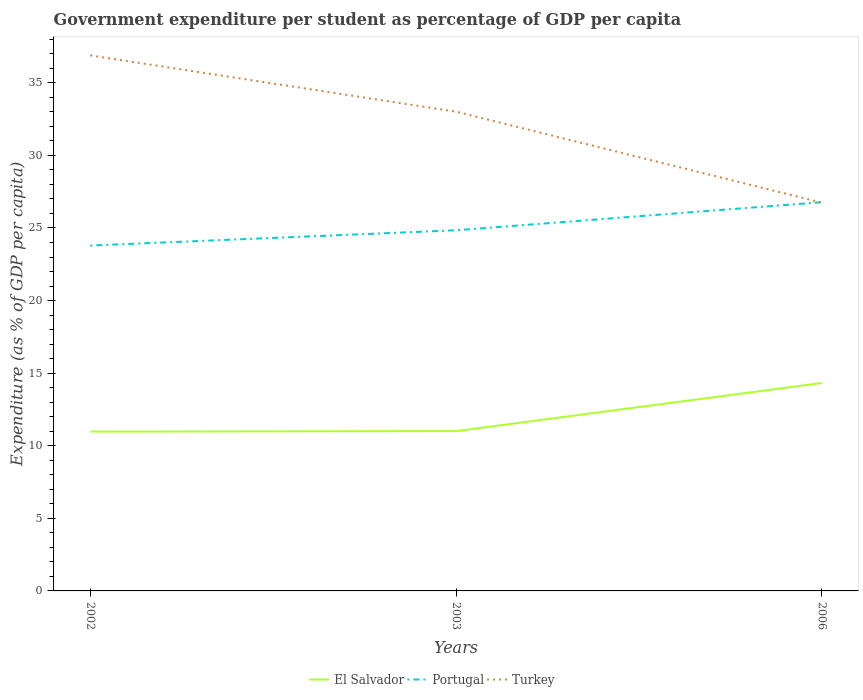How many different coloured lines are there?
Your answer should be compact. 3. Is the number of lines equal to the number of legend labels?
Provide a succinct answer. Yes. Across all years, what is the maximum percentage of expenditure per student in El Salvador?
Ensure brevity in your answer.  10.97. In which year was the percentage of expenditure per student in Portugal maximum?
Make the answer very short. 2002. What is the total percentage of expenditure per student in Portugal in the graph?
Ensure brevity in your answer.  -2.99. What is the difference between the highest and the second highest percentage of expenditure per student in Portugal?
Keep it short and to the point. 2.99. What is the difference between the highest and the lowest percentage of expenditure per student in Turkey?
Provide a succinct answer. 2. Is the percentage of expenditure per student in El Salvador strictly greater than the percentage of expenditure per student in Portugal over the years?
Offer a very short reply. Yes. How many lines are there?
Keep it short and to the point. 3. How many years are there in the graph?
Ensure brevity in your answer.  3. What is the difference between two consecutive major ticks on the Y-axis?
Ensure brevity in your answer.  5. Are the values on the major ticks of Y-axis written in scientific E-notation?
Your answer should be very brief. No. Does the graph contain any zero values?
Provide a short and direct response. No. Does the graph contain grids?
Provide a succinct answer. No. Where does the legend appear in the graph?
Give a very brief answer. Bottom center. What is the title of the graph?
Make the answer very short. Government expenditure per student as percentage of GDP per capita. Does "Solomon Islands" appear as one of the legend labels in the graph?
Your answer should be compact. No. What is the label or title of the Y-axis?
Your answer should be very brief. Expenditure (as % of GDP per capita). What is the Expenditure (as % of GDP per capita) in El Salvador in 2002?
Your answer should be very brief. 10.97. What is the Expenditure (as % of GDP per capita) in Portugal in 2002?
Provide a short and direct response. 23.79. What is the Expenditure (as % of GDP per capita) in Turkey in 2002?
Keep it short and to the point. 36.89. What is the Expenditure (as % of GDP per capita) in El Salvador in 2003?
Provide a short and direct response. 11.01. What is the Expenditure (as % of GDP per capita) of Portugal in 2003?
Provide a succinct answer. 24.84. What is the Expenditure (as % of GDP per capita) in Turkey in 2003?
Keep it short and to the point. 33.01. What is the Expenditure (as % of GDP per capita) in El Salvador in 2006?
Provide a short and direct response. 14.32. What is the Expenditure (as % of GDP per capita) of Portugal in 2006?
Your answer should be very brief. 26.78. What is the Expenditure (as % of GDP per capita) of Turkey in 2006?
Give a very brief answer. 26.74. Across all years, what is the maximum Expenditure (as % of GDP per capita) in El Salvador?
Your answer should be compact. 14.32. Across all years, what is the maximum Expenditure (as % of GDP per capita) of Portugal?
Offer a terse response. 26.78. Across all years, what is the maximum Expenditure (as % of GDP per capita) of Turkey?
Offer a very short reply. 36.89. Across all years, what is the minimum Expenditure (as % of GDP per capita) in El Salvador?
Give a very brief answer. 10.97. Across all years, what is the minimum Expenditure (as % of GDP per capita) of Portugal?
Offer a very short reply. 23.79. Across all years, what is the minimum Expenditure (as % of GDP per capita) of Turkey?
Give a very brief answer. 26.74. What is the total Expenditure (as % of GDP per capita) of El Salvador in the graph?
Keep it short and to the point. 36.3. What is the total Expenditure (as % of GDP per capita) of Portugal in the graph?
Offer a very short reply. 75.41. What is the total Expenditure (as % of GDP per capita) in Turkey in the graph?
Give a very brief answer. 96.64. What is the difference between the Expenditure (as % of GDP per capita) in El Salvador in 2002 and that in 2003?
Give a very brief answer. -0.04. What is the difference between the Expenditure (as % of GDP per capita) in Portugal in 2002 and that in 2003?
Offer a very short reply. -1.05. What is the difference between the Expenditure (as % of GDP per capita) of Turkey in 2002 and that in 2003?
Provide a short and direct response. 3.88. What is the difference between the Expenditure (as % of GDP per capita) in El Salvador in 2002 and that in 2006?
Provide a short and direct response. -3.35. What is the difference between the Expenditure (as % of GDP per capita) in Portugal in 2002 and that in 2006?
Offer a very short reply. -2.99. What is the difference between the Expenditure (as % of GDP per capita) in Turkey in 2002 and that in 2006?
Keep it short and to the point. 10.14. What is the difference between the Expenditure (as % of GDP per capita) in El Salvador in 2003 and that in 2006?
Your response must be concise. -3.31. What is the difference between the Expenditure (as % of GDP per capita) of Portugal in 2003 and that in 2006?
Your response must be concise. -1.93. What is the difference between the Expenditure (as % of GDP per capita) of Turkey in 2003 and that in 2006?
Make the answer very short. 6.27. What is the difference between the Expenditure (as % of GDP per capita) in El Salvador in 2002 and the Expenditure (as % of GDP per capita) in Portugal in 2003?
Your answer should be very brief. -13.87. What is the difference between the Expenditure (as % of GDP per capita) of El Salvador in 2002 and the Expenditure (as % of GDP per capita) of Turkey in 2003?
Make the answer very short. -22.04. What is the difference between the Expenditure (as % of GDP per capita) in Portugal in 2002 and the Expenditure (as % of GDP per capita) in Turkey in 2003?
Make the answer very short. -9.22. What is the difference between the Expenditure (as % of GDP per capita) in El Salvador in 2002 and the Expenditure (as % of GDP per capita) in Portugal in 2006?
Your response must be concise. -15.8. What is the difference between the Expenditure (as % of GDP per capita) of El Salvador in 2002 and the Expenditure (as % of GDP per capita) of Turkey in 2006?
Your answer should be very brief. -15.77. What is the difference between the Expenditure (as % of GDP per capita) in Portugal in 2002 and the Expenditure (as % of GDP per capita) in Turkey in 2006?
Provide a succinct answer. -2.95. What is the difference between the Expenditure (as % of GDP per capita) in El Salvador in 2003 and the Expenditure (as % of GDP per capita) in Portugal in 2006?
Give a very brief answer. -15.77. What is the difference between the Expenditure (as % of GDP per capita) of El Salvador in 2003 and the Expenditure (as % of GDP per capita) of Turkey in 2006?
Your answer should be compact. -15.73. What is the difference between the Expenditure (as % of GDP per capita) in Portugal in 2003 and the Expenditure (as % of GDP per capita) in Turkey in 2006?
Give a very brief answer. -1.9. What is the average Expenditure (as % of GDP per capita) of El Salvador per year?
Offer a very short reply. 12.1. What is the average Expenditure (as % of GDP per capita) in Portugal per year?
Your answer should be compact. 25.14. What is the average Expenditure (as % of GDP per capita) in Turkey per year?
Your answer should be very brief. 32.21. In the year 2002, what is the difference between the Expenditure (as % of GDP per capita) in El Salvador and Expenditure (as % of GDP per capita) in Portugal?
Your answer should be compact. -12.82. In the year 2002, what is the difference between the Expenditure (as % of GDP per capita) of El Salvador and Expenditure (as % of GDP per capita) of Turkey?
Your response must be concise. -25.91. In the year 2002, what is the difference between the Expenditure (as % of GDP per capita) in Portugal and Expenditure (as % of GDP per capita) in Turkey?
Your answer should be compact. -13.1. In the year 2003, what is the difference between the Expenditure (as % of GDP per capita) in El Salvador and Expenditure (as % of GDP per capita) in Portugal?
Offer a terse response. -13.83. In the year 2003, what is the difference between the Expenditure (as % of GDP per capita) of El Salvador and Expenditure (as % of GDP per capita) of Turkey?
Provide a short and direct response. -22. In the year 2003, what is the difference between the Expenditure (as % of GDP per capita) in Portugal and Expenditure (as % of GDP per capita) in Turkey?
Give a very brief answer. -8.17. In the year 2006, what is the difference between the Expenditure (as % of GDP per capita) of El Salvador and Expenditure (as % of GDP per capita) of Portugal?
Offer a very short reply. -12.45. In the year 2006, what is the difference between the Expenditure (as % of GDP per capita) of El Salvador and Expenditure (as % of GDP per capita) of Turkey?
Keep it short and to the point. -12.42. In the year 2006, what is the difference between the Expenditure (as % of GDP per capita) in Portugal and Expenditure (as % of GDP per capita) in Turkey?
Offer a very short reply. 0.03. What is the ratio of the Expenditure (as % of GDP per capita) in El Salvador in 2002 to that in 2003?
Your answer should be compact. 1. What is the ratio of the Expenditure (as % of GDP per capita) of Portugal in 2002 to that in 2003?
Provide a succinct answer. 0.96. What is the ratio of the Expenditure (as % of GDP per capita) of Turkey in 2002 to that in 2003?
Your answer should be very brief. 1.12. What is the ratio of the Expenditure (as % of GDP per capita) in El Salvador in 2002 to that in 2006?
Ensure brevity in your answer.  0.77. What is the ratio of the Expenditure (as % of GDP per capita) of Portugal in 2002 to that in 2006?
Give a very brief answer. 0.89. What is the ratio of the Expenditure (as % of GDP per capita) of Turkey in 2002 to that in 2006?
Give a very brief answer. 1.38. What is the ratio of the Expenditure (as % of GDP per capita) of El Salvador in 2003 to that in 2006?
Provide a short and direct response. 0.77. What is the ratio of the Expenditure (as % of GDP per capita) of Portugal in 2003 to that in 2006?
Ensure brevity in your answer.  0.93. What is the ratio of the Expenditure (as % of GDP per capita) of Turkey in 2003 to that in 2006?
Your answer should be compact. 1.23. What is the difference between the highest and the second highest Expenditure (as % of GDP per capita) in El Salvador?
Your response must be concise. 3.31. What is the difference between the highest and the second highest Expenditure (as % of GDP per capita) in Portugal?
Your response must be concise. 1.93. What is the difference between the highest and the second highest Expenditure (as % of GDP per capita) in Turkey?
Keep it short and to the point. 3.88. What is the difference between the highest and the lowest Expenditure (as % of GDP per capita) in El Salvador?
Make the answer very short. 3.35. What is the difference between the highest and the lowest Expenditure (as % of GDP per capita) of Portugal?
Ensure brevity in your answer.  2.99. What is the difference between the highest and the lowest Expenditure (as % of GDP per capita) of Turkey?
Keep it short and to the point. 10.14. 